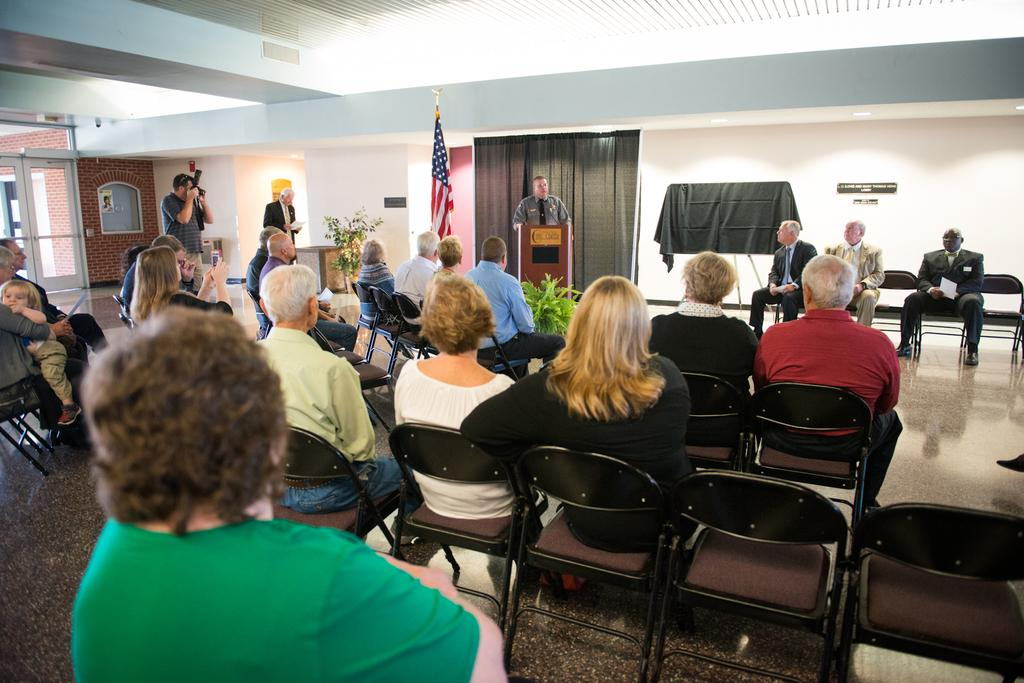What are the people in the image doing? The people in the image are sitting on chairs. What is the man at the front of the image doing? There is a man standing at a podium in the image. What can be seen in the background of the image? There is a flag, curtains, and a glass door in the background of the image. How many kittens are sitting on the man's head in the image? There are no kittens present in the image, so it is not possible to answer that question. 